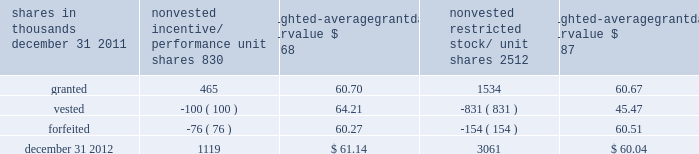To determine stock-based compensation expense , the grant- date fair value is applied to the options granted with a reduction for estimated forfeitures .
We recognize compensation expense for stock options on a straight-line basis over the pro rata vesting period .
At december 31 , 2011 and 2010 , options for 12337000 and 13397000 shares of common stock were exercisable at a weighted-average price of $ 106.08 and $ 118.21 , respectively .
The total intrinsic value of options exercised during 2012 , 2011 and 2010 was $ 37 million , $ 4 million and $ 5 million .
Cash received from option exercises under all incentive plans for 2012 , 2011 and 2010 was approximately $ 118 million , $ 41 million and $ 15 million , respectively .
The actual tax benefit realized for tax deduction purposes from option exercises under all incentive plans for 2012 , 2011 and 2010 was approximately $ 41 million , $ 14 million and $ 5 million , respectively .
There were no options granted in excess of market value in 2012 , 2011 or 2010 .
Shares of common stock available during the next year for the granting of options and other awards under the incentive plans were 29192854 at december 31 , 2012 .
Total shares of pnc common stock authorized for future issuance under equity compensation plans totaled 30537674 shares at december 31 , 2012 , which includes shares available for issuance under the incentive plans and the employee stock purchase plan ( espp ) as described below .
During 2012 , we issued approximately 1.7 million shares from treasury stock in connection with stock option exercise activity .
As with past exercise activity , we currently intend to utilize primarily treasury stock for any future stock option exercises .
Awards granted to non-employee directors in 2012 , 2011 and 2010 include 25620 , 27090 and 29040 deferred stock units , respectively , awarded under the outside directors deferred stock unit plan .
A deferred stock unit is a phantom share of our common stock , which requires liability accounting treatment until such awards are paid to the participants as cash .
As there are no vesting or service requirements on these awards , total compensation expense is recognized in full on awarded deferred stock units on the date of grant .
Incentive/performance unit share awards and restricted stock/unit awards the fair value of nonvested incentive/performance unit share awards and restricted stock/unit awards is initially determined based on prices not less than the market value of our common stock price on the date of grant .
The value of certain incentive/ performance unit share awards is subsequently remeasured based on the achievement of one or more financial and other performance goals generally over a three-year period .
The personnel and compensation committee of the board of directors approves the final award payout with respect to incentive/performance unit share awards .
Restricted stock/unit awards have various vesting periods generally ranging from 36 months to 60 months .
Beginning in 2012 , we incorporated several risk-related performance changes to certain incentive compensation programs .
In addition to achieving certain financial performance metrics relative to our peers , the final payout amount will be subject to a negative adjustment if pnc fails to meet certain risk-related performance metrics as specified in the award agreement .
However , the p&cc has the discretion to reduce any or all of this negative adjustment under certain circumstances .
These awards have a three-year performance period and are payable in either stock or a combination of stock and cash .
Additionally , performance-based restricted share units were granted in 2012 to certain of our executives in lieu of stock options , with generally the same terms and conditions as the 2011 awards of the same .
The weighted-average grant-date fair value of incentive/ performance unit share awards and restricted stock/unit awards granted in 2012 , 2011 and 2010 was $ 60.68 , $ 63.25 and $ 54.59 per share , respectively .
We recognize compensation expense for such awards ratably over the corresponding vesting and/or performance periods for each type of program .
Table 130 : nonvested incentive/performance unit share awards and restricted stock/unit awards 2013 rollforward shares in thousands nonvested incentive/ performance unit shares weighted- average date fair nonvested restricted stock/ shares weighted- average date fair .
In the chart above , the unit shares and related weighted- average grant-date fair value of the incentive/performance awards exclude the effect of dividends on the underlying shares , as those dividends will be paid in cash .
At december 31 , 2012 , there was $ 86 million of unrecognized deferred compensation expense related to nonvested share- based compensation arrangements granted under the incentive plans .
This cost is expected to be recognized as expense over a period of no longer than five years .
The total fair value of incentive/performance unit share and restricted stock/unit awards vested during 2012 , 2011 and 2010 was approximately $ 55 million , $ 52 million and $ 39 million , respectively .
The pnc financial services group , inc .
2013 form 10-k 203 .
What was the average weighted-average grant-date fair value of incentive/ performance unit share awards and restricted stock/unit awards granted in 2012 and 2011? 
Computations: ((60.68 + 63.25) / 2)
Answer: 61.965. 